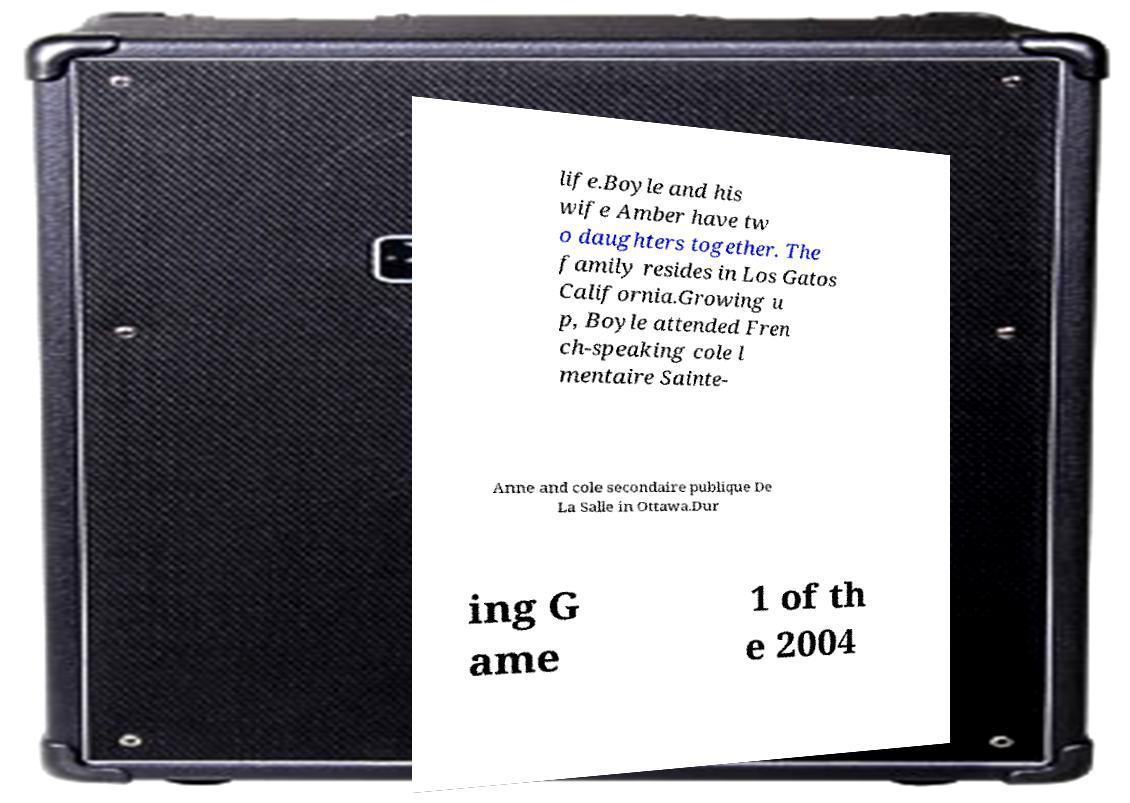There's text embedded in this image that I need extracted. Can you transcribe it verbatim? life.Boyle and his wife Amber have tw o daughters together. The family resides in Los Gatos California.Growing u p, Boyle attended Fren ch-speaking cole l mentaire Sainte- Anne and cole secondaire publique De La Salle in Ottawa.Dur ing G ame 1 of th e 2004 